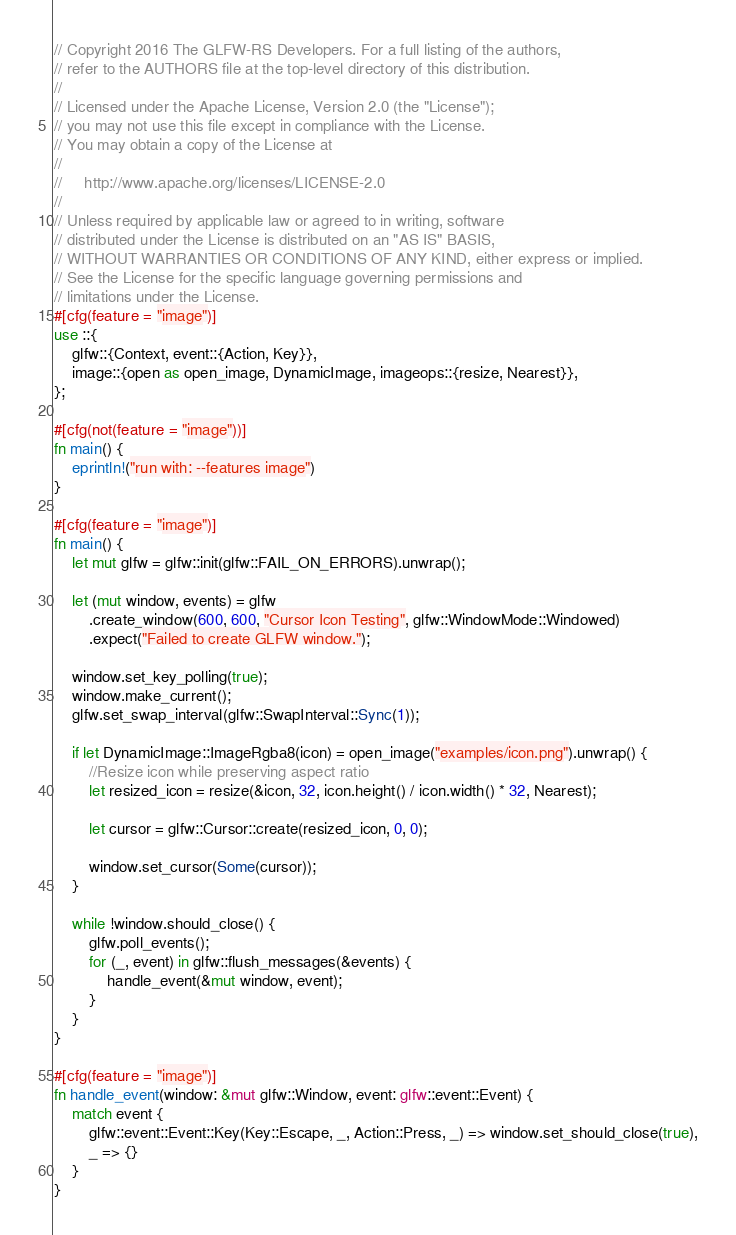Convert code to text. <code><loc_0><loc_0><loc_500><loc_500><_Rust_>// Copyright 2016 The GLFW-RS Developers. For a full listing of the authors,
// refer to the AUTHORS file at the top-level directory of this distribution.
//
// Licensed under the Apache License, Version 2.0 (the "License");
// you may not use this file except in compliance with the License.
// You may obtain a copy of the License at
//
//     http://www.apache.org/licenses/LICENSE-2.0
//
// Unless required by applicable law or agreed to in writing, software
// distributed under the License is distributed on an "AS IS" BASIS,
// WITHOUT WARRANTIES OR CONDITIONS OF ANY KIND, either express or implied.
// See the License for the specific language governing permissions and
// limitations under the License.
#[cfg(feature = "image")]
use ::{
    glfw::{Context, event::{Action, Key}},
    image::{open as open_image, DynamicImage, imageops::{resize, Nearest}},
};

#[cfg(not(feature = "image"))]
fn main() {
    eprintln!("run with: --features image")
}

#[cfg(feature = "image")]
fn main() {
    let mut glfw = glfw::init(glfw::FAIL_ON_ERRORS).unwrap();

    let (mut window, events) = glfw
        .create_window(600, 600, "Cursor Icon Testing", glfw::WindowMode::Windowed)
        .expect("Failed to create GLFW window.");

    window.set_key_polling(true);
    window.make_current();
    glfw.set_swap_interval(glfw::SwapInterval::Sync(1));

    if let DynamicImage::ImageRgba8(icon) = open_image("examples/icon.png").unwrap() {
        //Resize icon while preserving aspect ratio
        let resized_icon = resize(&icon, 32, icon.height() / icon.width() * 32, Nearest);

        let cursor = glfw::Cursor::create(resized_icon, 0, 0);

        window.set_cursor(Some(cursor));
    }

    while !window.should_close() {
        glfw.poll_events();
        for (_, event) in glfw::flush_messages(&events) {
            handle_event(&mut window, event);
        }
    }
}

#[cfg(feature = "image")]
fn handle_event(window: &mut glfw::Window, event: glfw::event::Event) {
    match event {
        glfw::event::Event::Key(Key::Escape, _, Action::Press, _) => window.set_should_close(true),
        _ => {}
    }
}
</code> 